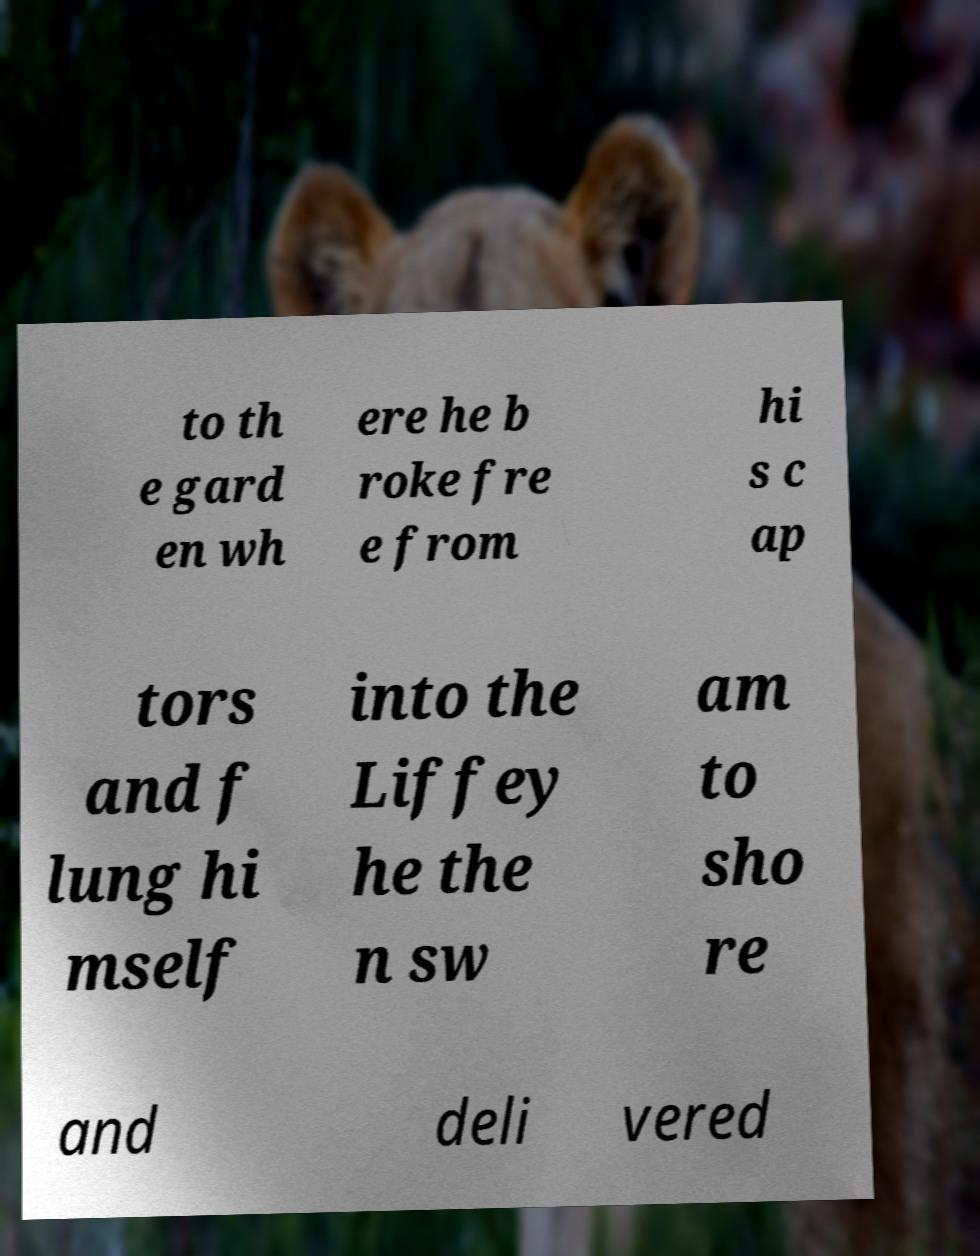Can you read and provide the text displayed in the image?This photo seems to have some interesting text. Can you extract and type it out for me? to th e gard en wh ere he b roke fre e from hi s c ap tors and f lung hi mself into the Liffey he the n sw am to sho re and deli vered 